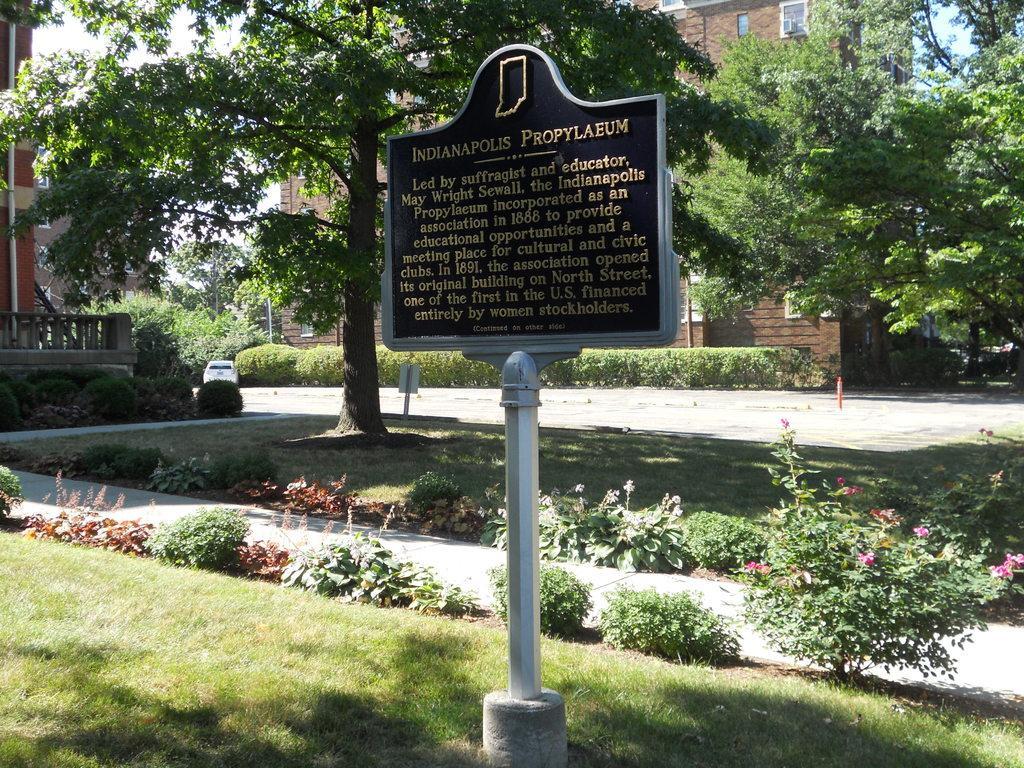How would you summarize this image in a sentence or two? In the picture we can see a grass surface on it, we can see a pole with a board and some information on it and behind it also we can see a tree and in the background, we can see the building with windows and near it, we can see some plants and to the opposite side also we can see a building and behind it we can see a part of the sky from the tree. 